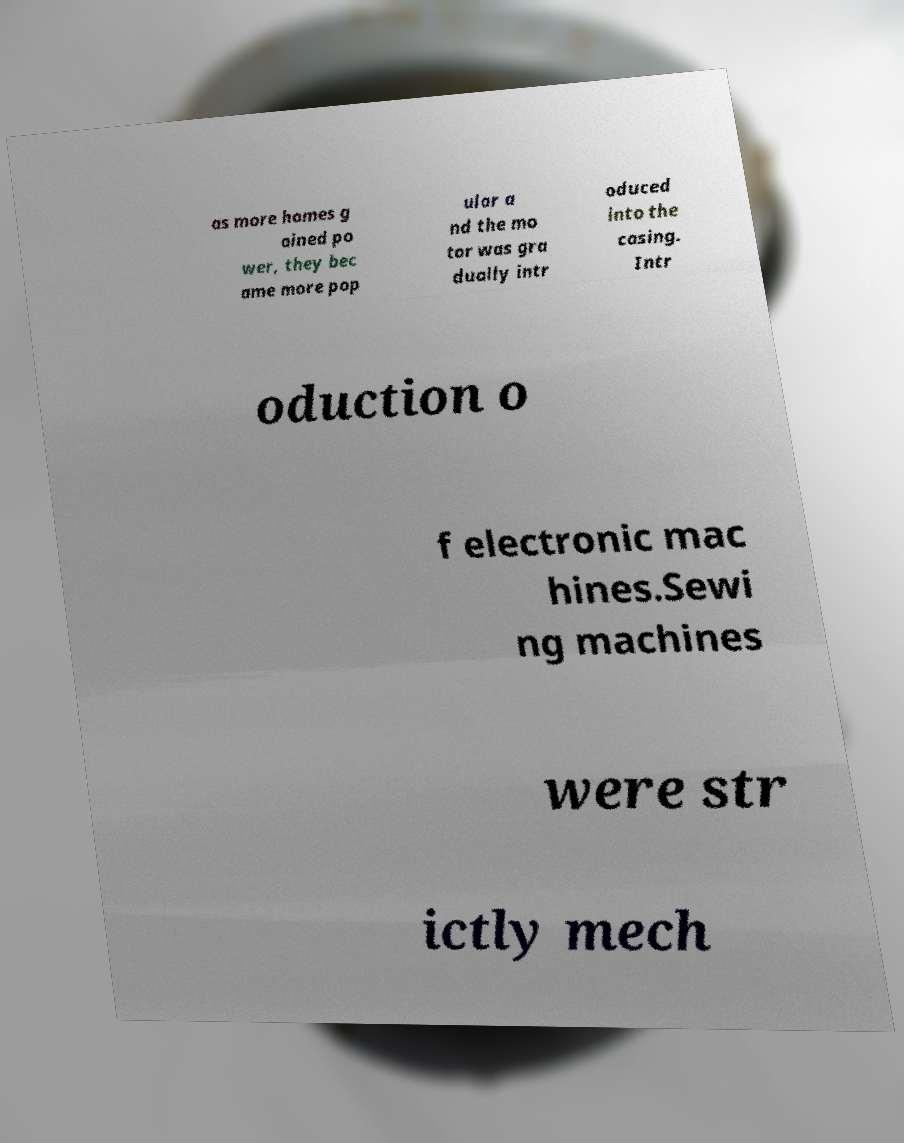What messages or text are displayed in this image? I need them in a readable, typed format. as more homes g ained po wer, they bec ame more pop ular a nd the mo tor was gra dually intr oduced into the casing. Intr oduction o f electronic mac hines.Sewi ng machines were str ictly mech 